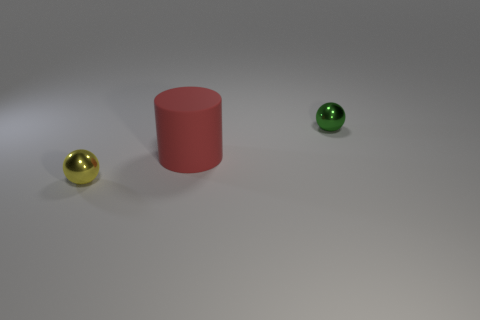Add 3 small red rubber balls. How many objects exist? 6 Subtract 1 balls. How many balls are left? 1 Subtract all cylinders. How many objects are left? 2 Subtract 0 gray balls. How many objects are left? 3 Subtract all blue cylinders. Subtract all blue spheres. How many cylinders are left? 1 Subtract all large gray cylinders. Subtract all red matte things. How many objects are left? 2 Add 3 small green things. How many small green things are left? 4 Add 1 small yellow metallic objects. How many small yellow metallic objects exist? 2 Subtract all green spheres. How many spheres are left? 1 